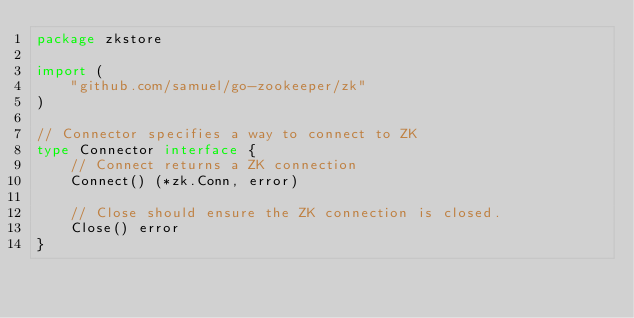<code> <loc_0><loc_0><loc_500><loc_500><_Go_>package zkstore

import (
	"github.com/samuel/go-zookeeper/zk"
)

// Connector specifies a way to connect to ZK
type Connector interface {
	// Connect returns a ZK connection
	Connect() (*zk.Conn, error)

	// Close should ensure the ZK connection is closed.
	Close() error
}
</code> 